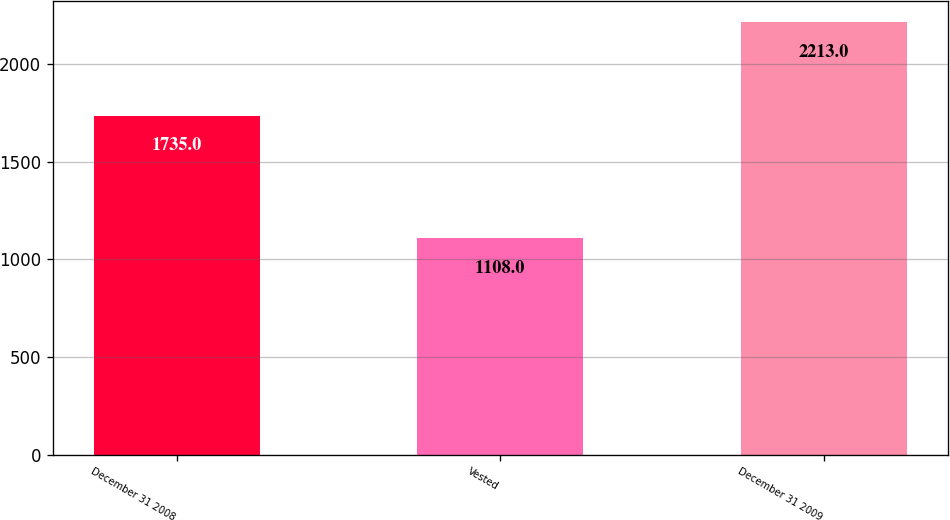Convert chart. <chart><loc_0><loc_0><loc_500><loc_500><bar_chart><fcel>December 31 2008<fcel>Vested<fcel>December 31 2009<nl><fcel>1735<fcel>1108<fcel>2213<nl></chart> 